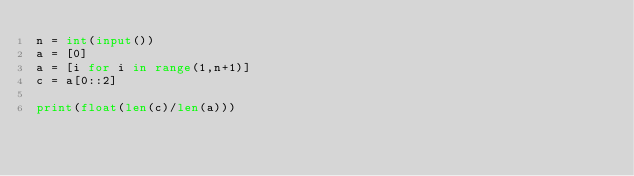Convert code to text. <code><loc_0><loc_0><loc_500><loc_500><_Python_>n = int(input())
a = [0]
a = [i for i in range(1,n+1)]
c = a[0::2]

print(float(len(c)/len(a)))</code> 